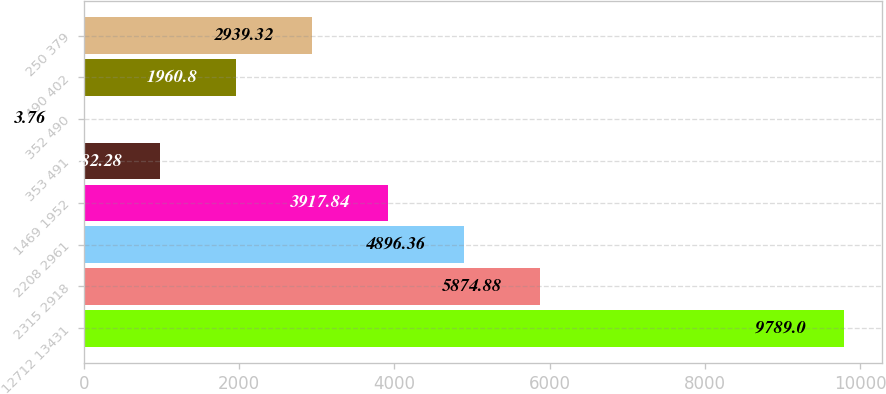Convert chart to OTSL. <chart><loc_0><loc_0><loc_500><loc_500><bar_chart><fcel>12712 13431<fcel>2315 2918<fcel>2208 2961<fcel>1469 1952<fcel>353 491<fcel>352 490<fcel>490 402<fcel>250 379<nl><fcel>9789<fcel>5874.88<fcel>4896.36<fcel>3917.84<fcel>982.28<fcel>3.76<fcel>1960.8<fcel>2939.32<nl></chart> 